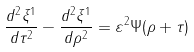<formula> <loc_0><loc_0><loc_500><loc_500>\frac { d ^ { 2 } \xi ^ { 1 } } { d \tau ^ { 2 } } - \frac { d ^ { 2 } \xi ^ { 1 } } { d \rho ^ { 2 } } = \varepsilon ^ { 2 } \Psi ( \rho + \tau )</formula> 